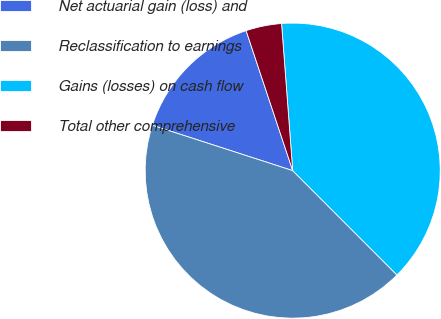<chart> <loc_0><loc_0><loc_500><loc_500><pie_chart><fcel>Net actuarial gain (loss) and<fcel>Reclassification to earnings<fcel>Gains (losses) on cash flow<fcel>Total other comprehensive<nl><fcel>14.91%<fcel>42.47%<fcel>38.71%<fcel>3.91%<nl></chart> 